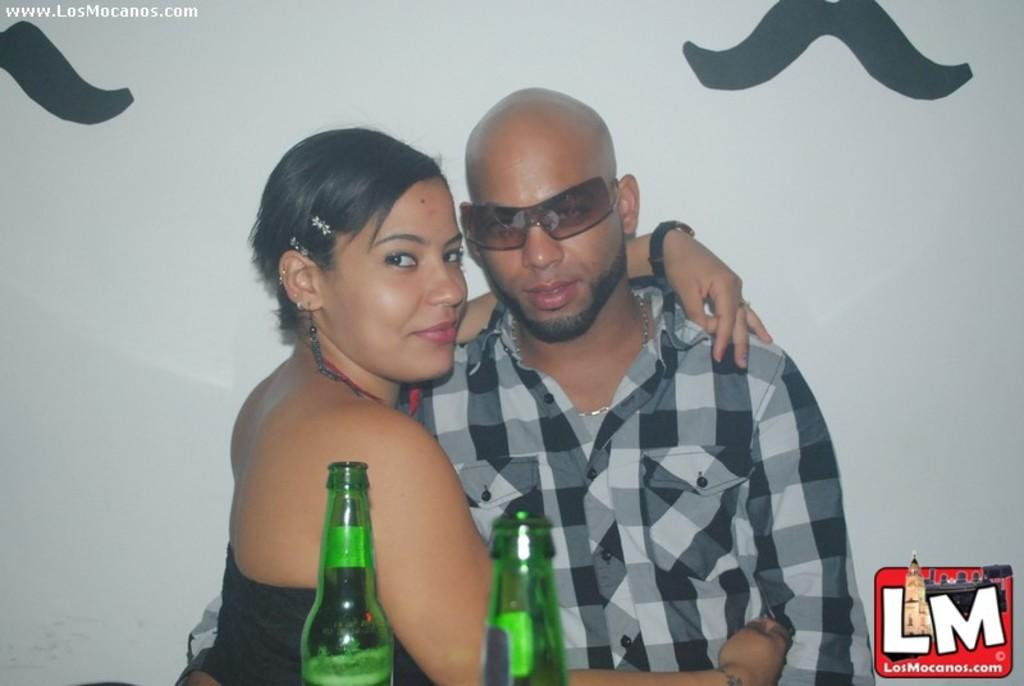How many people are in the image? There are two persons in the image: a man and a woman. What objects are in front of the two persons? There are two bottles in front of the two persons. Where can a logo be found in the image? The logo is in the bottom right corner of the image. What type of food is the woman eating in the image? There is no food visible in the image, so it cannot be determined what the woman might be eating. 